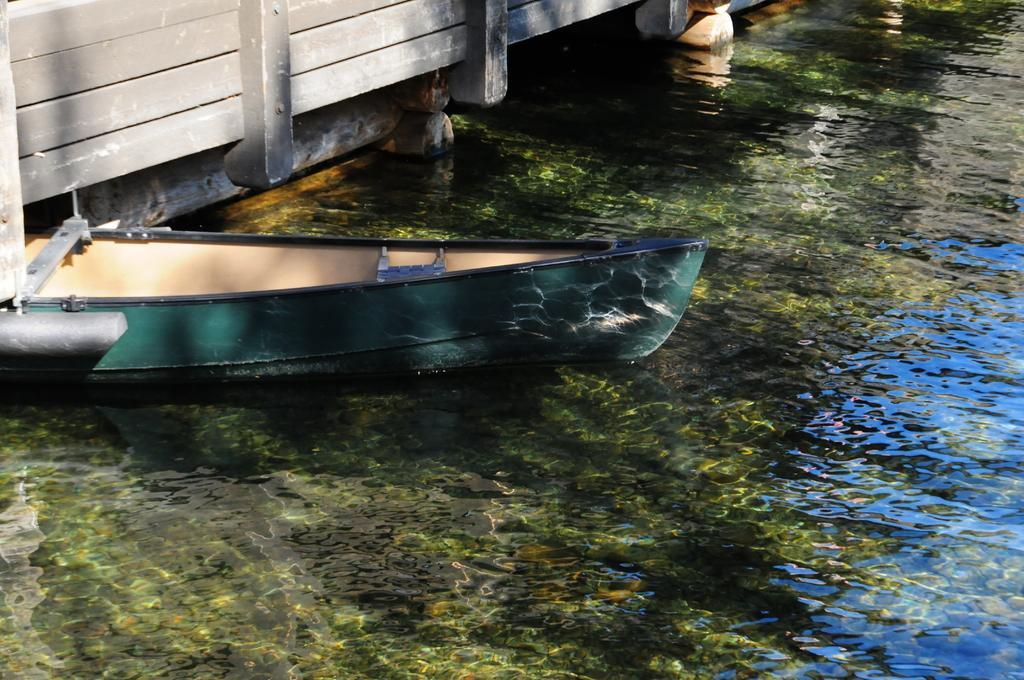What is the main subject of the image? The main subject of the image is a boat. Where is the boat located? The boat is on the water. What other object can be seen in the image? There is a fence in the image. What type of system is being observed in the image? There is no system being observed in the image; it features a boat on the water and a fence. How many mines are visible in the image? There are no mines present in the image. 